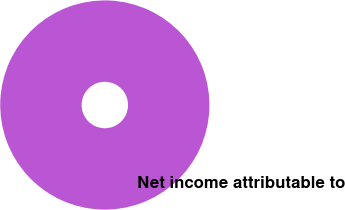Convert chart. <chart><loc_0><loc_0><loc_500><loc_500><pie_chart><fcel>Net income attributable to<nl><fcel>100.0%<nl></chart> 